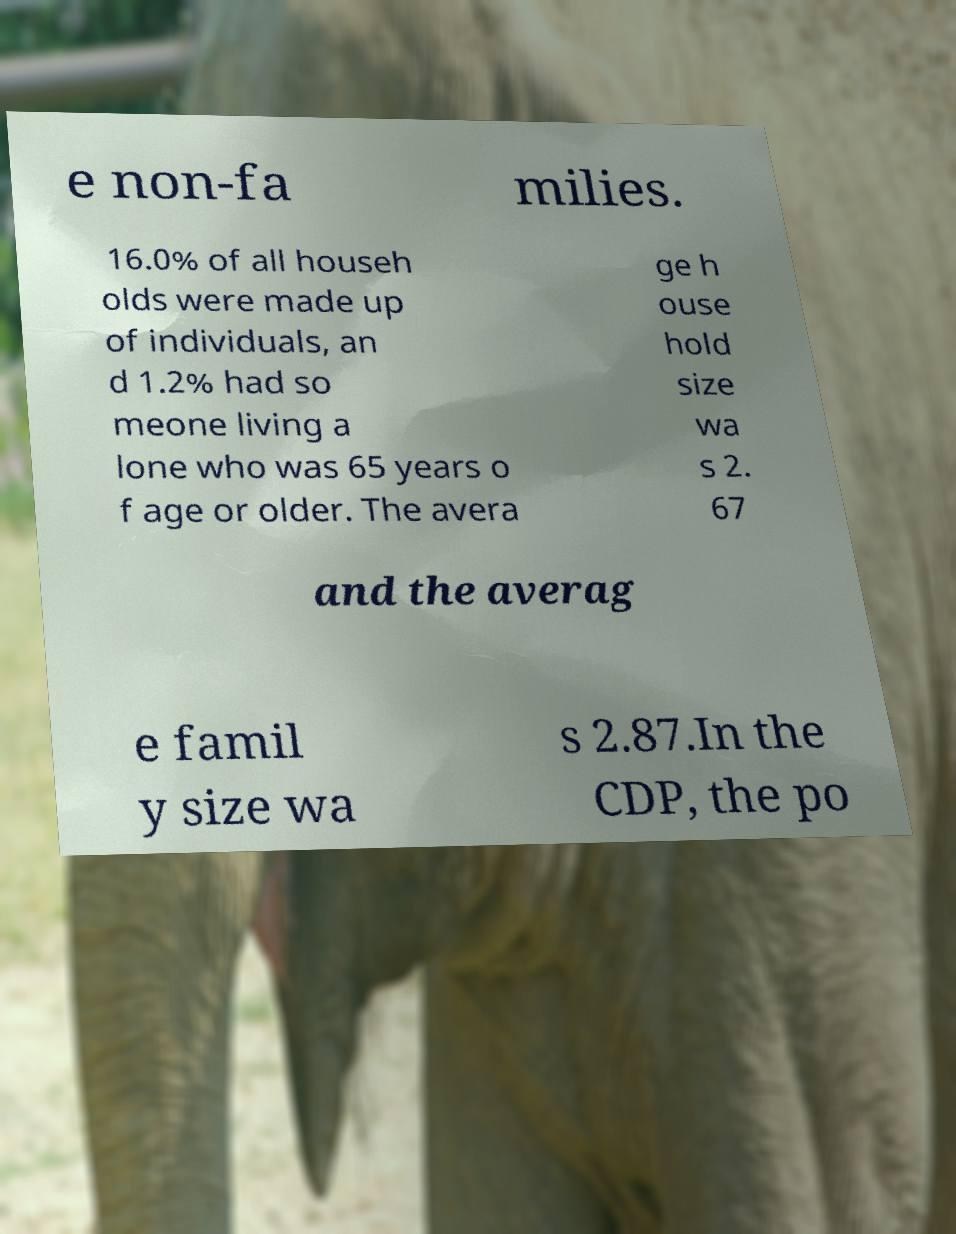For documentation purposes, I need the text within this image transcribed. Could you provide that? e non-fa milies. 16.0% of all househ olds were made up of individuals, an d 1.2% had so meone living a lone who was 65 years o f age or older. The avera ge h ouse hold size wa s 2. 67 and the averag e famil y size wa s 2.87.In the CDP, the po 